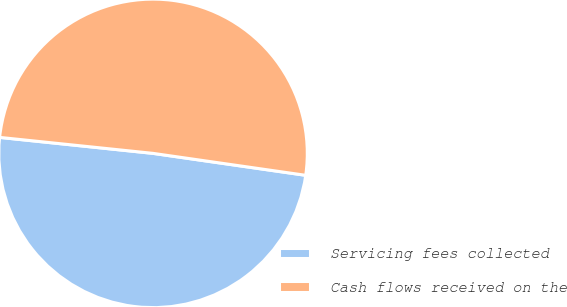<chart> <loc_0><loc_0><loc_500><loc_500><pie_chart><fcel>Servicing fees collected<fcel>Cash flows received on the<nl><fcel>49.38%<fcel>50.62%<nl></chart> 